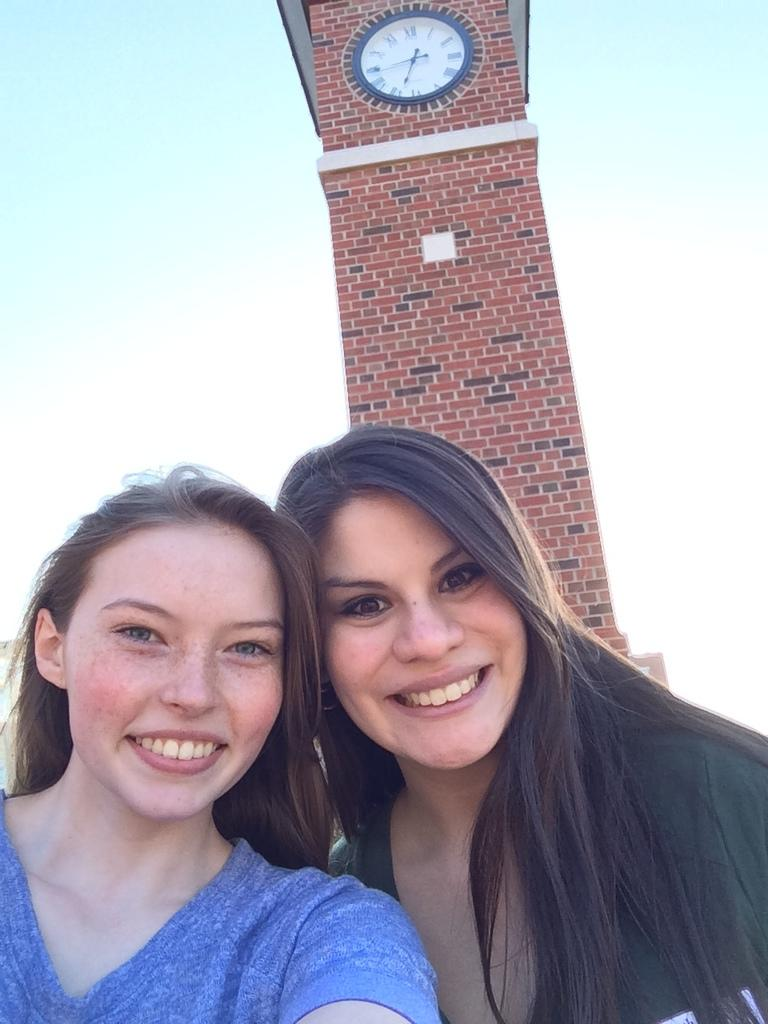How many people are in the image? There are two women in the image. What are the women wearing? The women are wearing t-shirts. What expression do the women have in the image? The women are smiling. What are the women doing in the image? The women are giving a pose for the picture. What can be seen in the background of the image? There is a clock tower in the background of the image. What is visible at the top of the image? The sky is visible at the top of the image. Can you tell me how many nests are visible in the image? There are no nests present in the image. What type of creature is shown interacting with the clock tower in the image? There is no creature shown interacting with the clock tower in the image; only the women and the clock tower are present. 